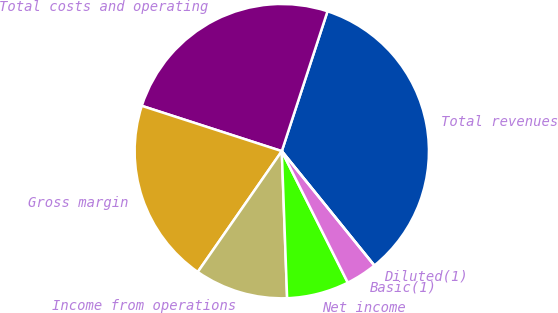Convert chart to OTSL. <chart><loc_0><loc_0><loc_500><loc_500><pie_chart><fcel>Total revenues<fcel>Total costs and operating<fcel>Gross margin<fcel>Income from operations<fcel>Net income<fcel>Basic(1)<fcel>Diluted(1)<nl><fcel>34.15%<fcel>25.05%<fcel>20.31%<fcel>10.25%<fcel>6.83%<fcel>3.42%<fcel>0.0%<nl></chart> 